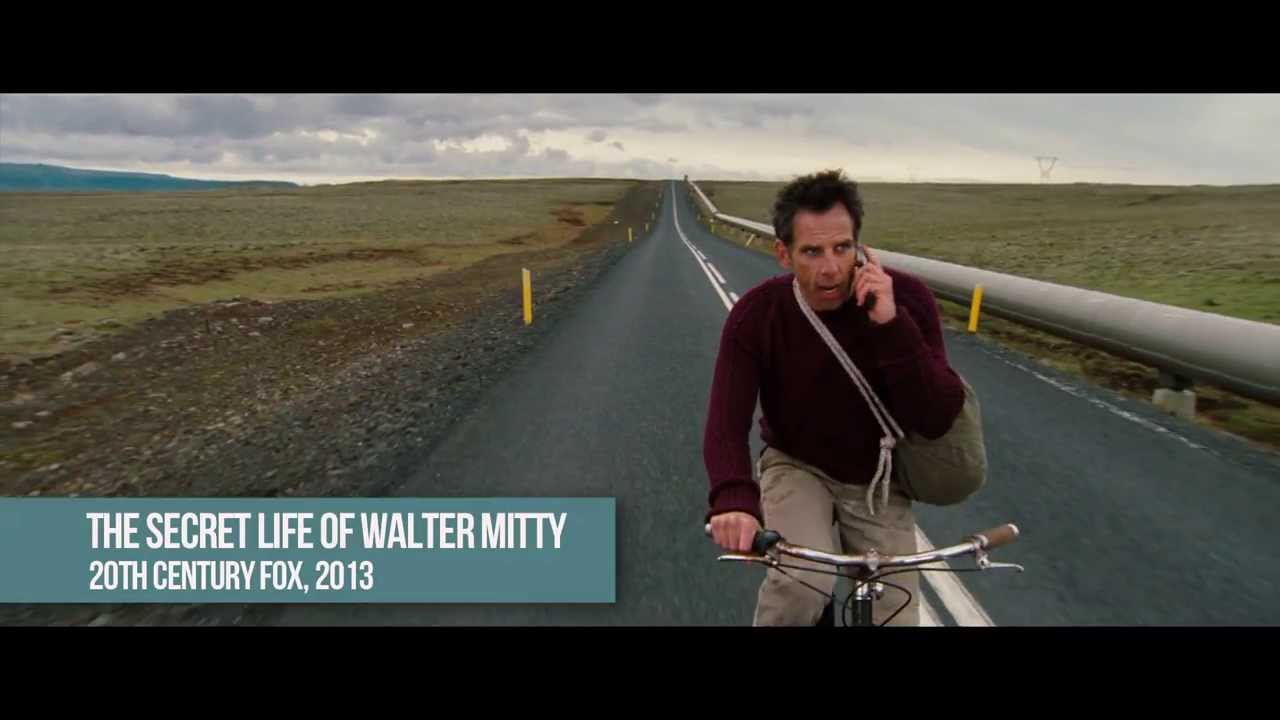Imagine this image as the cover of a novel. Write a gripping first paragraph for the story. Daniel's legs burned as he pedaled furiously against the relentless wind, the cold air stinging his face like shards of glass. The road stretched endlessly before him, a stark black ribbon slicing through the desolate wasteland that was once a thriving countryside. Clouds loomed overhead, pregnant with unspoken threats, as he clutched the relic—a small, black notebook containing secrets that could either save or doom what was left of humanity. He glanced over his shoulder, the haunting echo of his pursuers' engines growing louder, each second more precious than the last. 